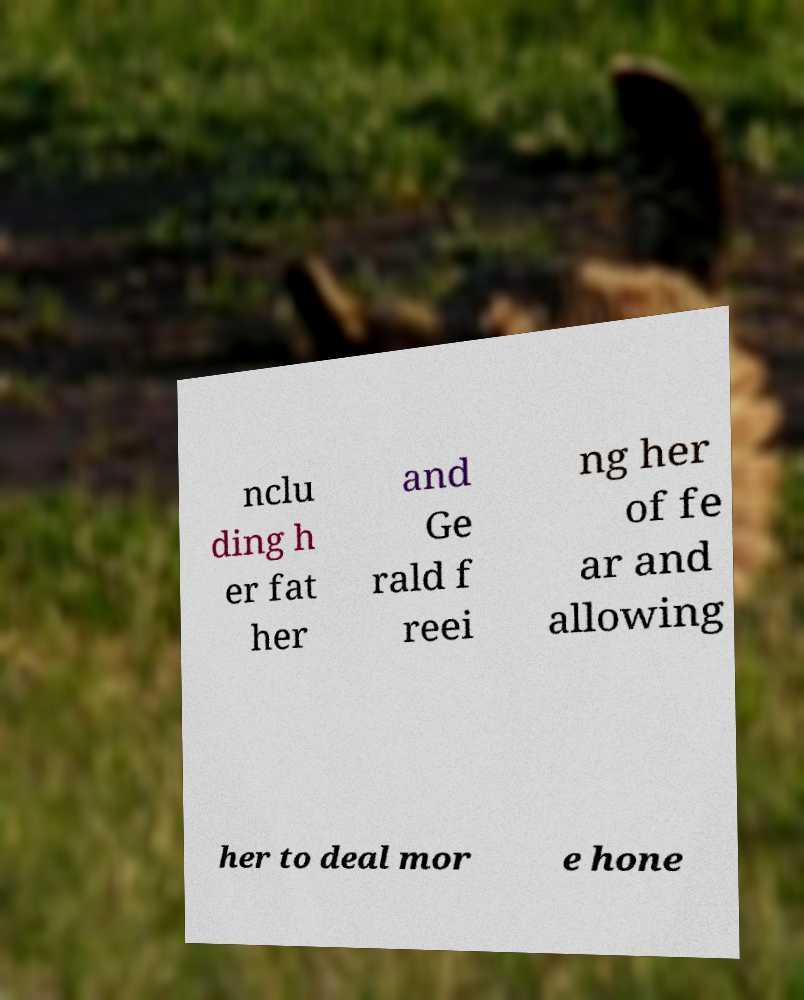Please read and relay the text visible in this image. What does it say? nclu ding h er fat her and Ge rald f reei ng her of fe ar and allowing her to deal mor e hone 